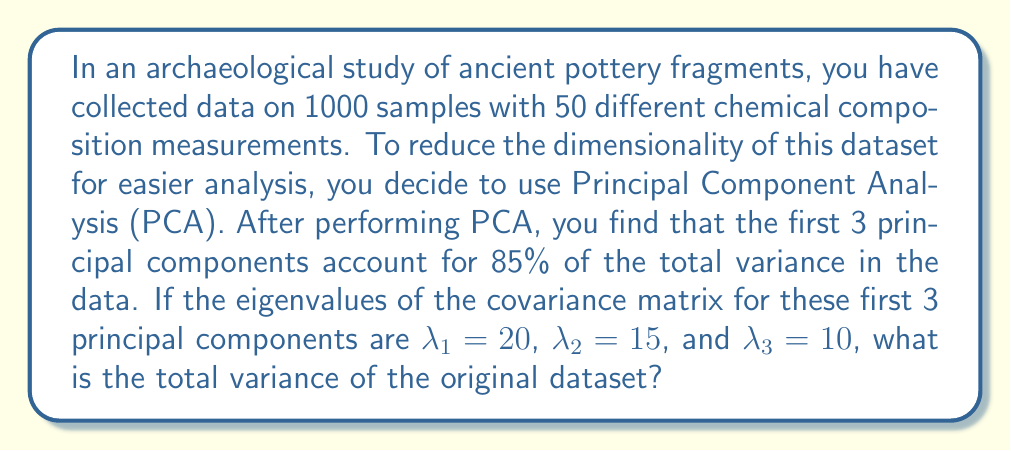Could you help me with this problem? Let's approach this step-by-step:

1) In PCA, each principal component corresponds to an eigenvalue of the covariance matrix. The eigenvalue represents the amount of variance explained by that principal component.

2) We're told that the first 3 principal components account for 85% of the total variance, and we're given their eigenvalues:
   $\lambda_1 = 20$, $\lambda_2 = 15$, $\lambda_3 = 10$

3) The sum of these eigenvalues represents 85% of the total variance:
   $20 + 15 + 10 = 45$

4) Let's call the total variance $V$. We can set up an equation:
   $45 = 0.85V$

5) To solve for $V$, we divide both sides by 0.85:
   $V = 45 / 0.85$

6) Calculating this:
   $V = 52.94117647...$

7) Rounding to two decimal places:
   $V \approx 52.94$

Therefore, the total variance of the original dataset is approximately 52.94.
Answer: 52.94 